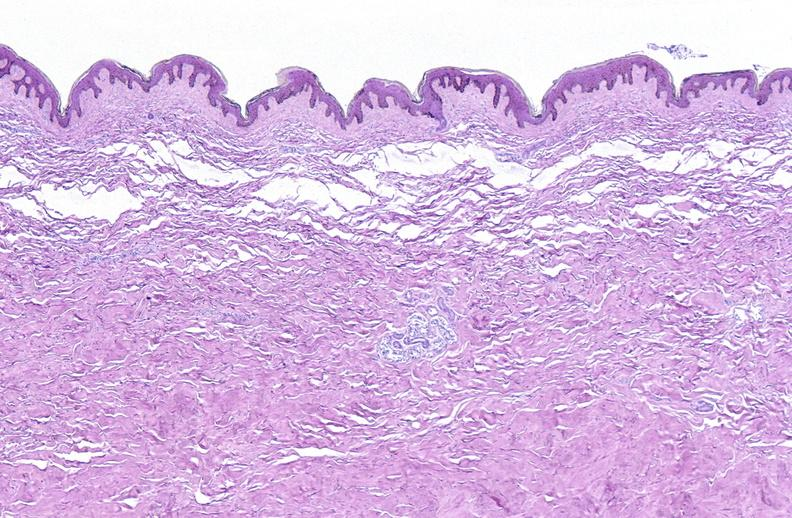does infarcts show scleroderma?
Answer the question using a single word or phrase. No 